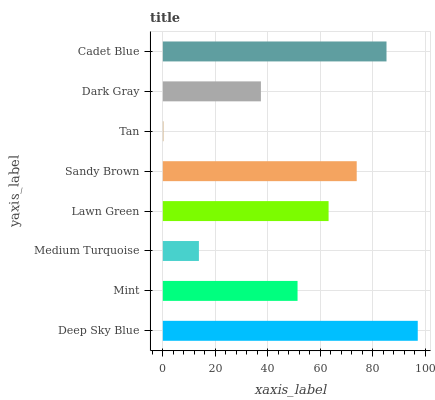Is Tan the minimum?
Answer yes or no. Yes. Is Deep Sky Blue the maximum?
Answer yes or no. Yes. Is Mint the minimum?
Answer yes or no. No. Is Mint the maximum?
Answer yes or no. No. Is Deep Sky Blue greater than Mint?
Answer yes or no. Yes. Is Mint less than Deep Sky Blue?
Answer yes or no. Yes. Is Mint greater than Deep Sky Blue?
Answer yes or no. No. Is Deep Sky Blue less than Mint?
Answer yes or no. No. Is Lawn Green the high median?
Answer yes or no. Yes. Is Mint the low median?
Answer yes or no. Yes. Is Dark Gray the high median?
Answer yes or no. No. Is Dark Gray the low median?
Answer yes or no. No. 